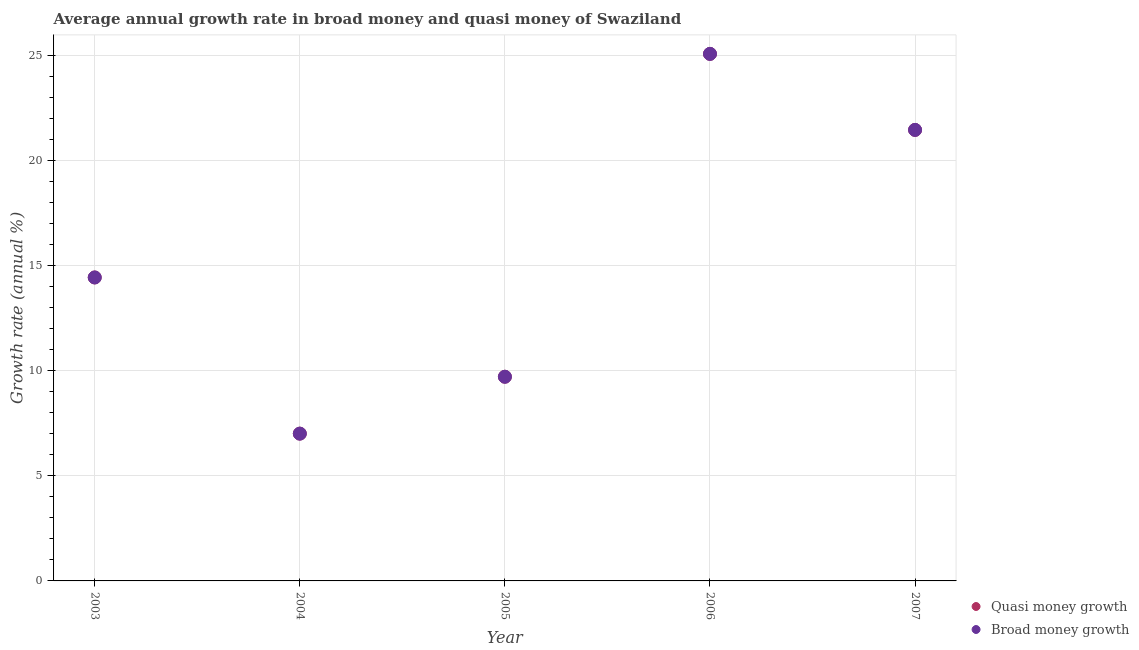How many different coloured dotlines are there?
Offer a very short reply. 2. What is the annual growth rate in quasi money in 2007?
Provide a short and direct response. 21.47. Across all years, what is the maximum annual growth rate in quasi money?
Your answer should be very brief. 25.08. Across all years, what is the minimum annual growth rate in quasi money?
Give a very brief answer. 7.01. What is the total annual growth rate in broad money in the graph?
Keep it short and to the point. 77.72. What is the difference between the annual growth rate in quasi money in 2004 and that in 2006?
Provide a short and direct response. -18.07. What is the difference between the annual growth rate in quasi money in 2003 and the annual growth rate in broad money in 2005?
Your response must be concise. 4.72. What is the average annual growth rate in quasi money per year?
Offer a very short reply. 15.54. In how many years, is the annual growth rate in quasi money greater than 6 %?
Offer a very short reply. 5. What is the ratio of the annual growth rate in quasi money in 2004 to that in 2006?
Your answer should be compact. 0.28. What is the difference between the highest and the second highest annual growth rate in broad money?
Ensure brevity in your answer.  3.62. What is the difference between the highest and the lowest annual growth rate in broad money?
Offer a very short reply. 18.07. In how many years, is the annual growth rate in broad money greater than the average annual growth rate in broad money taken over all years?
Your response must be concise. 2. Is the sum of the annual growth rate in quasi money in 2003 and 2005 greater than the maximum annual growth rate in broad money across all years?
Offer a terse response. No. Is the annual growth rate in broad money strictly greater than the annual growth rate in quasi money over the years?
Offer a very short reply. No. What is the difference between two consecutive major ticks on the Y-axis?
Your response must be concise. 5. Are the values on the major ticks of Y-axis written in scientific E-notation?
Make the answer very short. No. Does the graph contain grids?
Give a very brief answer. Yes. Where does the legend appear in the graph?
Keep it short and to the point. Bottom right. How many legend labels are there?
Give a very brief answer. 2. What is the title of the graph?
Give a very brief answer. Average annual growth rate in broad money and quasi money of Swaziland. What is the label or title of the Y-axis?
Your answer should be very brief. Growth rate (annual %). What is the Growth rate (annual %) in Quasi money growth in 2003?
Your answer should be very brief. 14.44. What is the Growth rate (annual %) in Broad money growth in 2003?
Ensure brevity in your answer.  14.44. What is the Growth rate (annual %) in Quasi money growth in 2004?
Ensure brevity in your answer.  7.01. What is the Growth rate (annual %) of Broad money growth in 2004?
Keep it short and to the point. 7.01. What is the Growth rate (annual %) of Quasi money growth in 2005?
Your response must be concise. 9.72. What is the Growth rate (annual %) of Broad money growth in 2005?
Your answer should be compact. 9.72. What is the Growth rate (annual %) in Quasi money growth in 2006?
Provide a succinct answer. 25.08. What is the Growth rate (annual %) in Broad money growth in 2006?
Make the answer very short. 25.08. What is the Growth rate (annual %) in Quasi money growth in 2007?
Make the answer very short. 21.47. What is the Growth rate (annual %) in Broad money growth in 2007?
Offer a terse response. 21.47. Across all years, what is the maximum Growth rate (annual %) of Quasi money growth?
Your answer should be compact. 25.08. Across all years, what is the maximum Growth rate (annual %) of Broad money growth?
Your answer should be compact. 25.08. Across all years, what is the minimum Growth rate (annual %) in Quasi money growth?
Offer a very short reply. 7.01. Across all years, what is the minimum Growth rate (annual %) of Broad money growth?
Your response must be concise. 7.01. What is the total Growth rate (annual %) in Quasi money growth in the graph?
Your answer should be compact. 77.72. What is the total Growth rate (annual %) in Broad money growth in the graph?
Provide a short and direct response. 77.72. What is the difference between the Growth rate (annual %) in Quasi money growth in 2003 and that in 2004?
Give a very brief answer. 7.43. What is the difference between the Growth rate (annual %) of Broad money growth in 2003 and that in 2004?
Keep it short and to the point. 7.43. What is the difference between the Growth rate (annual %) in Quasi money growth in 2003 and that in 2005?
Ensure brevity in your answer.  4.72. What is the difference between the Growth rate (annual %) of Broad money growth in 2003 and that in 2005?
Provide a succinct answer. 4.72. What is the difference between the Growth rate (annual %) of Quasi money growth in 2003 and that in 2006?
Provide a succinct answer. -10.64. What is the difference between the Growth rate (annual %) in Broad money growth in 2003 and that in 2006?
Your answer should be compact. -10.64. What is the difference between the Growth rate (annual %) in Quasi money growth in 2003 and that in 2007?
Keep it short and to the point. -7.02. What is the difference between the Growth rate (annual %) of Broad money growth in 2003 and that in 2007?
Give a very brief answer. -7.02. What is the difference between the Growth rate (annual %) of Quasi money growth in 2004 and that in 2005?
Keep it short and to the point. -2.71. What is the difference between the Growth rate (annual %) of Broad money growth in 2004 and that in 2005?
Ensure brevity in your answer.  -2.71. What is the difference between the Growth rate (annual %) in Quasi money growth in 2004 and that in 2006?
Ensure brevity in your answer.  -18.07. What is the difference between the Growth rate (annual %) in Broad money growth in 2004 and that in 2006?
Provide a short and direct response. -18.07. What is the difference between the Growth rate (annual %) of Quasi money growth in 2004 and that in 2007?
Offer a terse response. -14.46. What is the difference between the Growth rate (annual %) in Broad money growth in 2004 and that in 2007?
Offer a very short reply. -14.46. What is the difference between the Growth rate (annual %) in Quasi money growth in 2005 and that in 2006?
Your answer should be very brief. -15.37. What is the difference between the Growth rate (annual %) of Broad money growth in 2005 and that in 2006?
Your response must be concise. -15.37. What is the difference between the Growth rate (annual %) in Quasi money growth in 2005 and that in 2007?
Offer a very short reply. -11.75. What is the difference between the Growth rate (annual %) of Broad money growth in 2005 and that in 2007?
Keep it short and to the point. -11.75. What is the difference between the Growth rate (annual %) in Quasi money growth in 2006 and that in 2007?
Your answer should be compact. 3.62. What is the difference between the Growth rate (annual %) of Broad money growth in 2006 and that in 2007?
Ensure brevity in your answer.  3.62. What is the difference between the Growth rate (annual %) in Quasi money growth in 2003 and the Growth rate (annual %) in Broad money growth in 2004?
Your answer should be compact. 7.43. What is the difference between the Growth rate (annual %) of Quasi money growth in 2003 and the Growth rate (annual %) of Broad money growth in 2005?
Your answer should be very brief. 4.72. What is the difference between the Growth rate (annual %) of Quasi money growth in 2003 and the Growth rate (annual %) of Broad money growth in 2006?
Ensure brevity in your answer.  -10.64. What is the difference between the Growth rate (annual %) of Quasi money growth in 2003 and the Growth rate (annual %) of Broad money growth in 2007?
Make the answer very short. -7.02. What is the difference between the Growth rate (annual %) of Quasi money growth in 2004 and the Growth rate (annual %) of Broad money growth in 2005?
Offer a very short reply. -2.71. What is the difference between the Growth rate (annual %) of Quasi money growth in 2004 and the Growth rate (annual %) of Broad money growth in 2006?
Provide a succinct answer. -18.07. What is the difference between the Growth rate (annual %) of Quasi money growth in 2004 and the Growth rate (annual %) of Broad money growth in 2007?
Provide a short and direct response. -14.46. What is the difference between the Growth rate (annual %) in Quasi money growth in 2005 and the Growth rate (annual %) in Broad money growth in 2006?
Ensure brevity in your answer.  -15.37. What is the difference between the Growth rate (annual %) in Quasi money growth in 2005 and the Growth rate (annual %) in Broad money growth in 2007?
Your response must be concise. -11.75. What is the difference between the Growth rate (annual %) in Quasi money growth in 2006 and the Growth rate (annual %) in Broad money growth in 2007?
Offer a very short reply. 3.62. What is the average Growth rate (annual %) of Quasi money growth per year?
Your answer should be very brief. 15.54. What is the average Growth rate (annual %) in Broad money growth per year?
Provide a succinct answer. 15.54. In the year 2003, what is the difference between the Growth rate (annual %) of Quasi money growth and Growth rate (annual %) of Broad money growth?
Ensure brevity in your answer.  0. In the year 2005, what is the difference between the Growth rate (annual %) in Quasi money growth and Growth rate (annual %) in Broad money growth?
Provide a succinct answer. 0. In the year 2007, what is the difference between the Growth rate (annual %) in Quasi money growth and Growth rate (annual %) in Broad money growth?
Your response must be concise. 0. What is the ratio of the Growth rate (annual %) of Quasi money growth in 2003 to that in 2004?
Give a very brief answer. 2.06. What is the ratio of the Growth rate (annual %) of Broad money growth in 2003 to that in 2004?
Make the answer very short. 2.06. What is the ratio of the Growth rate (annual %) in Quasi money growth in 2003 to that in 2005?
Your answer should be compact. 1.49. What is the ratio of the Growth rate (annual %) of Broad money growth in 2003 to that in 2005?
Provide a succinct answer. 1.49. What is the ratio of the Growth rate (annual %) in Quasi money growth in 2003 to that in 2006?
Ensure brevity in your answer.  0.58. What is the ratio of the Growth rate (annual %) in Broad money growth in 2003 to that in 2006?
Offer a terse response. 0.58. What is the ratio of the Growth rate (annual %) in Quasi money growth in 2003 to that in 2007?
Offer a terse response. 0.67. What is the ratio of the Growth rate (annual %) of Broad money growth in 2003 to that in 2007?
Give a very brief answer. 0.67. What is the ratio of the Growth rate (annual %) of Quasi money growth in 2004 to that in 2005?
Make the answer very short. 0.72. What is the ratio of the Growth rate (annual %) in Broad money growth in 2004 to that in 2005?
Your response must be concise. 0.72. What is the ratio of the Growth rate (annual %) of Quasi money growth in 2004 to that in 2006?
Provide a short and direct response. 0.28. What is the ratio of the Growth rate (annual %) in Broad money growth in 2004 to that in 2006?
Your response must be concise. 0.28. What is the ratio of the Growth rate (annual %) of Quasi money growth in 2004 to that in 2007?
Offer a very short reply. 0.33. What is the ratio of the Growth rate (annual %) in Broad money growth in 2004 to that in 2007?
Provide a short and direct response. 0.33. What is the ratio of the Growth rate (annual %) of Quasi money growth in 2005 to that in 2006?
Offer a very short reply. 0.39. What is the ratio of the Growth rate (annual %) in Broad money growth in 2005 to that in 2006?
Provide a short and direct response. 0.39. What is the ratio of the Growth rate (annual %) of Quasi money growth in 2005 to that in 2007?
Offer a terse response. 0.45. What is the ratio of the Growth rate (annual %) of Broad money growth in 2005 to that in 2007?
Provide a short and direct response. 0.45. What is the ratio of the Growth rate (annual %) of Quasi money growth in 2006 to that in 2007?
Ensure brevity in your answer.  1.17. What is the ratio of the Growth rate (annual %) of Broad money growth in 2006 to that in 2007?
Keep it short and to the point. 1.17. What is the difference between the highest and the second highest Growth rate (annual %) in Quasi money growth?
Your answer should be compact. 3.62. What is the difference between the highest and the second highest Growth rate (annual %) of Broad money growth?
Give a very brief answer. 3.62. What is the difference between the highest and the lowest Growth rate (annual %) in Quasi money growth?
Your answer should be very brief. 18.07. What is the difference between the highest and the lowest Growth rate (annual %) in Broad money growth?
Provide a succinct answer. 18.07. 